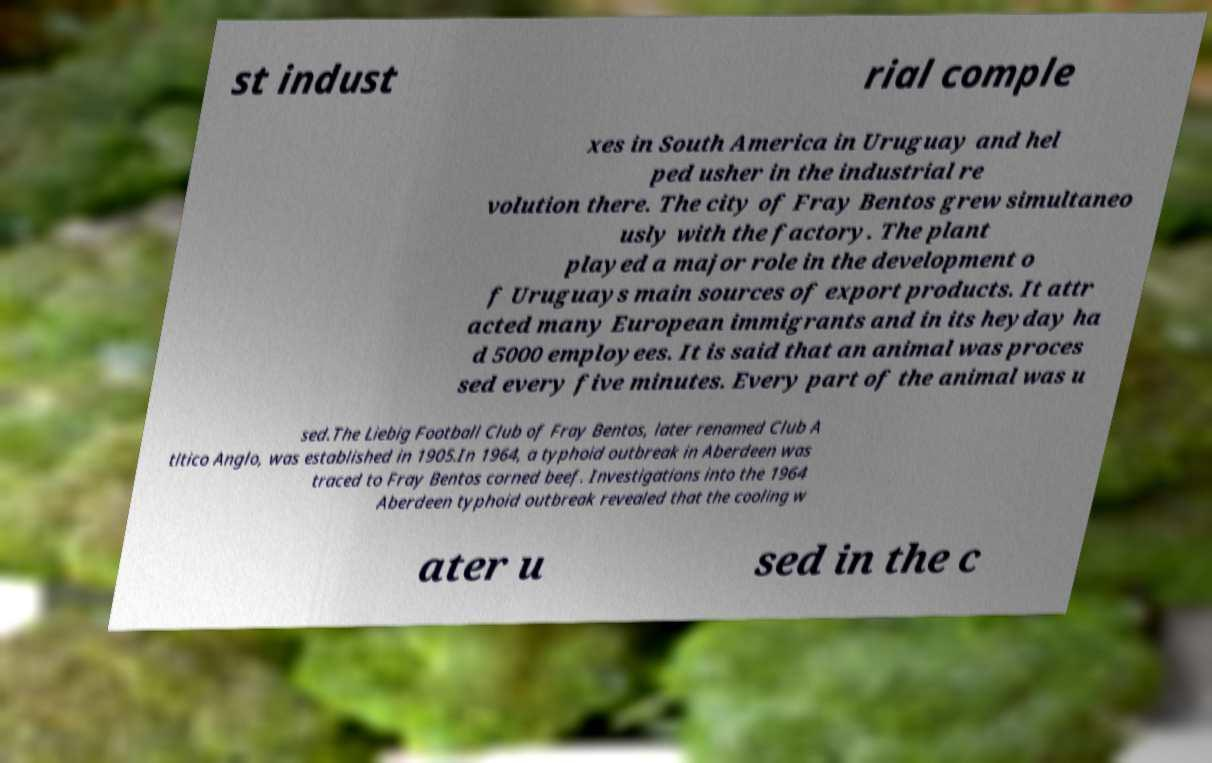Could you extract and type out the text from this image? st indust rial comple xes in South America in Uruguay and hel ped usher in the industrial re volution there. The city of Fray Bentos grew simultaneo usly with the factory. The plant played a major role in the development o f Uruguays main sources of export products. It attr acted many European immigrants and in its heyday ha d 5000 employees. It is said that an animal was proces sed every five minutes. Every part of the animal was u sed.The Liebig Football Club of Fray Bentos, later renamed Club A tltico Anglo, was established in 1905.In 1964, a typhoid outbreak in Aberdeen was traced to Fray Bentos corned beef. Investigations into the 1964 Aberdeen typhoid outbreak revealed that the cooling w ater u sed in the c 